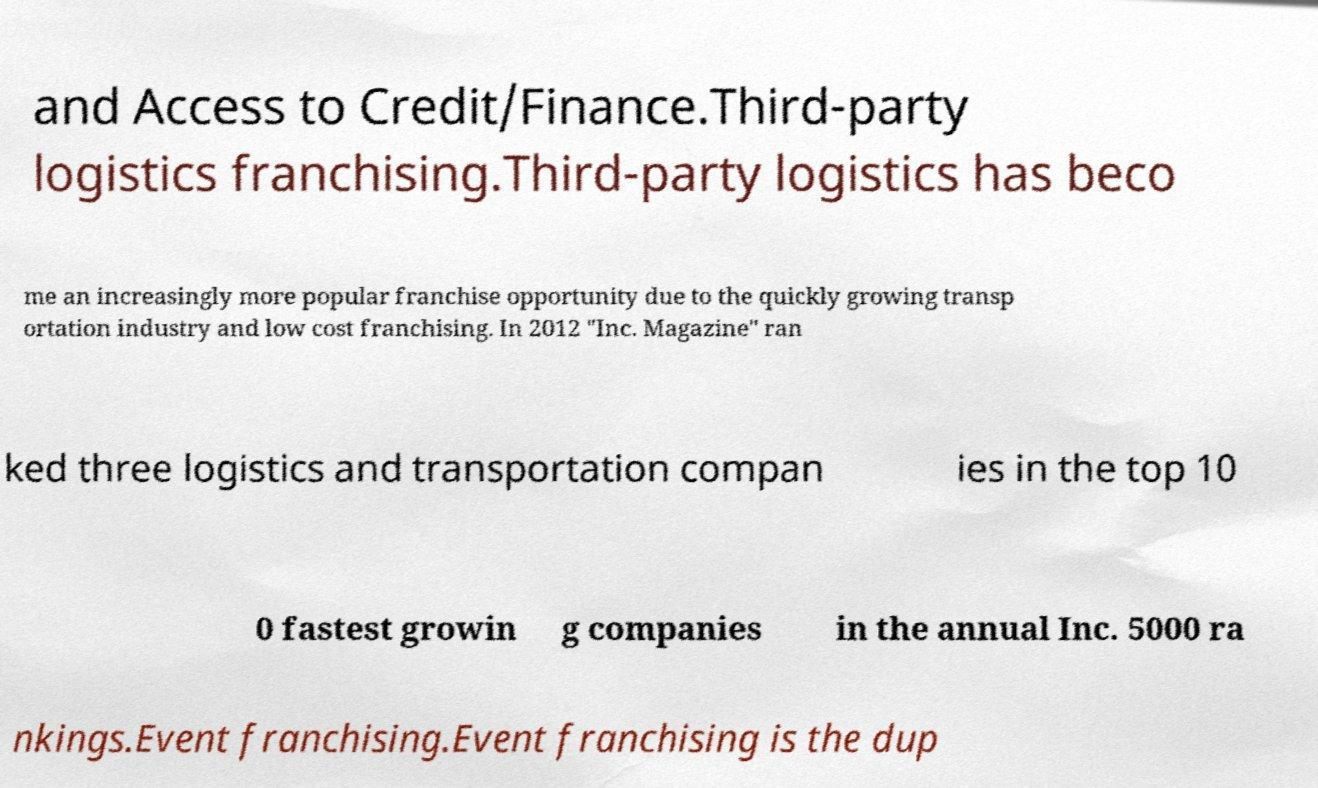Please read and relay the text visible in this image. What does it say? and Access to Credit/Finance.Third-party logistics franchising.Third-party logistics has beco me an increasingly more popular franchise opportunity due to the quickly growing transp ortation industry and low cost franchising. In 2012 "Inc. Magazine" ran ked three logistics and transportation compan ies in the top 10 0 fastest growin g companies in the annual Inc. 5000 ra nkings.Event franchising.Event franchising is the dup 